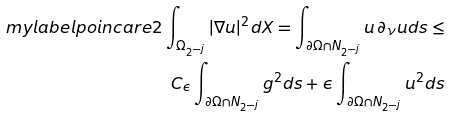<formula> <loc_0><loc_0><loc_500><loc_500>\ m y l a b e l { p o i n c a r e 2 } \int _ { \Omega _ { 2 ^ { - j } } } | \nabla u | ^ { 2 } d X = \int _ { \partial \Omega \cap N _ { 2 ^ { - j } } } u \, \partial _ { \nu } u d s \leq \\ C _ { \epsilon } \int _ { \partial \Omega \cap N _ { 2 ^ { - j } } } g ^ { 2 } d s + \epsilon \int _ { \partial \Omega \cap N _ { 2 ^ { - j } } } u ^ { 2 } d s</formula> 